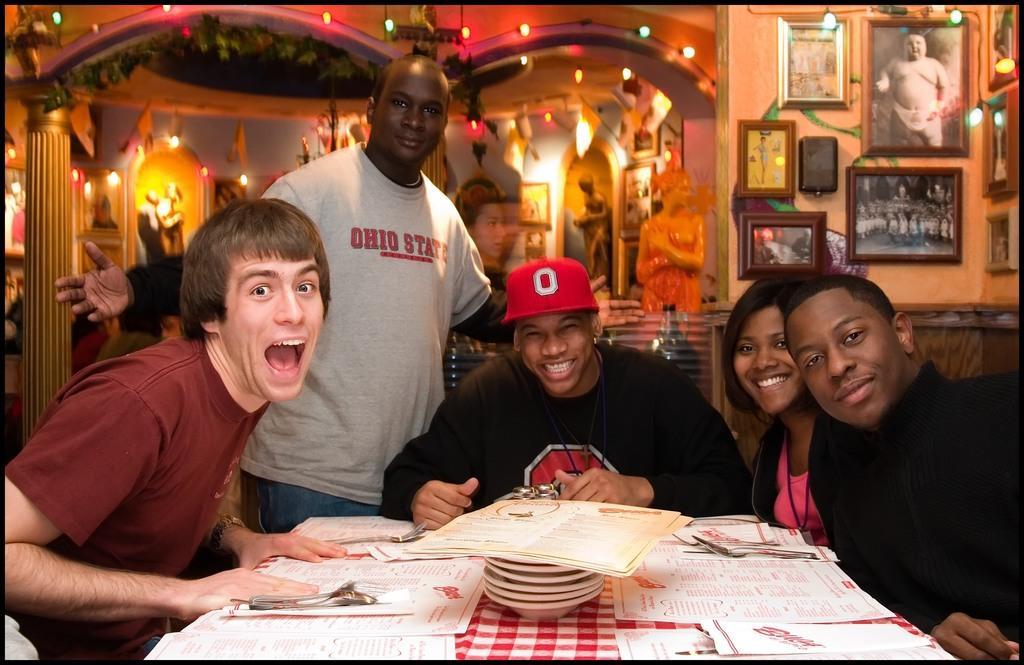In one or two sentences, can you explain what this image depicts? This picture is taken inside a restaurant. There are few people sitting on chairs at the table. On the table there are pile of plates and menu cards. In the background there is wall. There are picture frames and fairy lights hanging to the wall. There are sculptures behind them. 